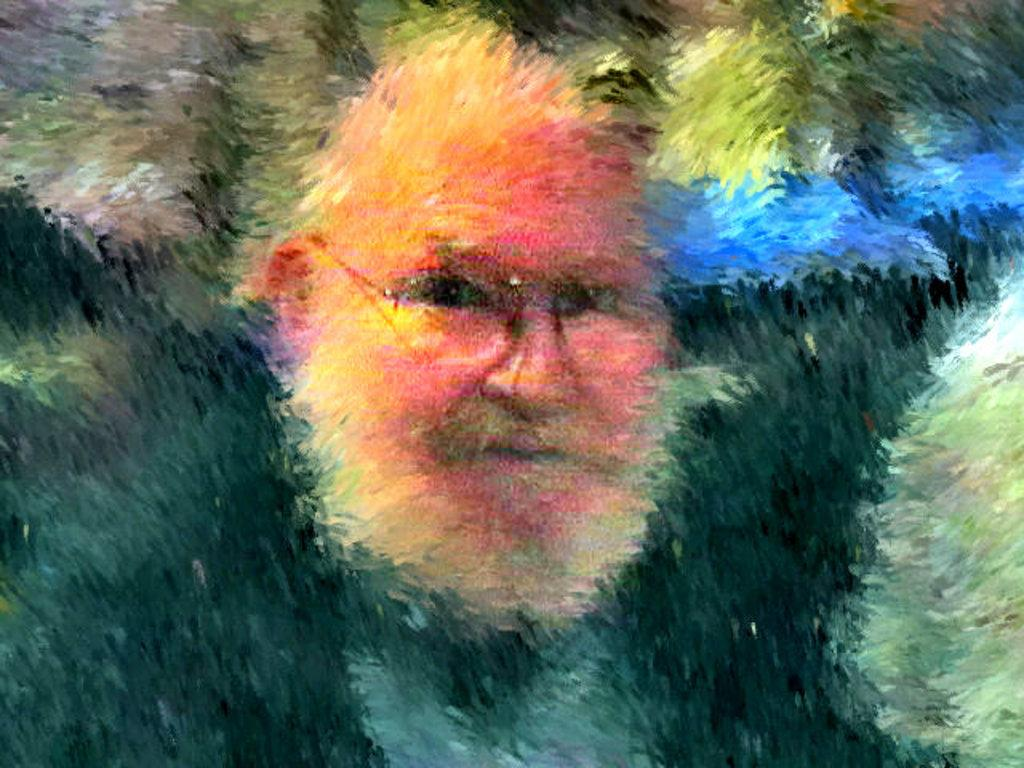What type of artwork is depicted in the image? The image is a painting. What is the main subject of the painting? There is a face of a person in the painting. What accessory is the person wearing in the painting? The person is wearing spectacles. How would you describe the background of the painting? The background of the painting has different colors. What is the tendency of the person in the painting to change their hairstyle? There is no information about the person's hairstyle or any tendency to change it in the image. 